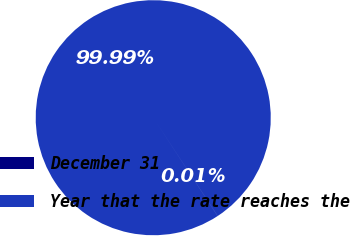Convert chart to OTSL. <chart><loc_0><loc_0><loc_500><loc_500><pie_chart><fcel>December 31<fcel>Year that the rate reaches the<nl><fcel>0.01%<fcel>99.99%<nl></chart> 